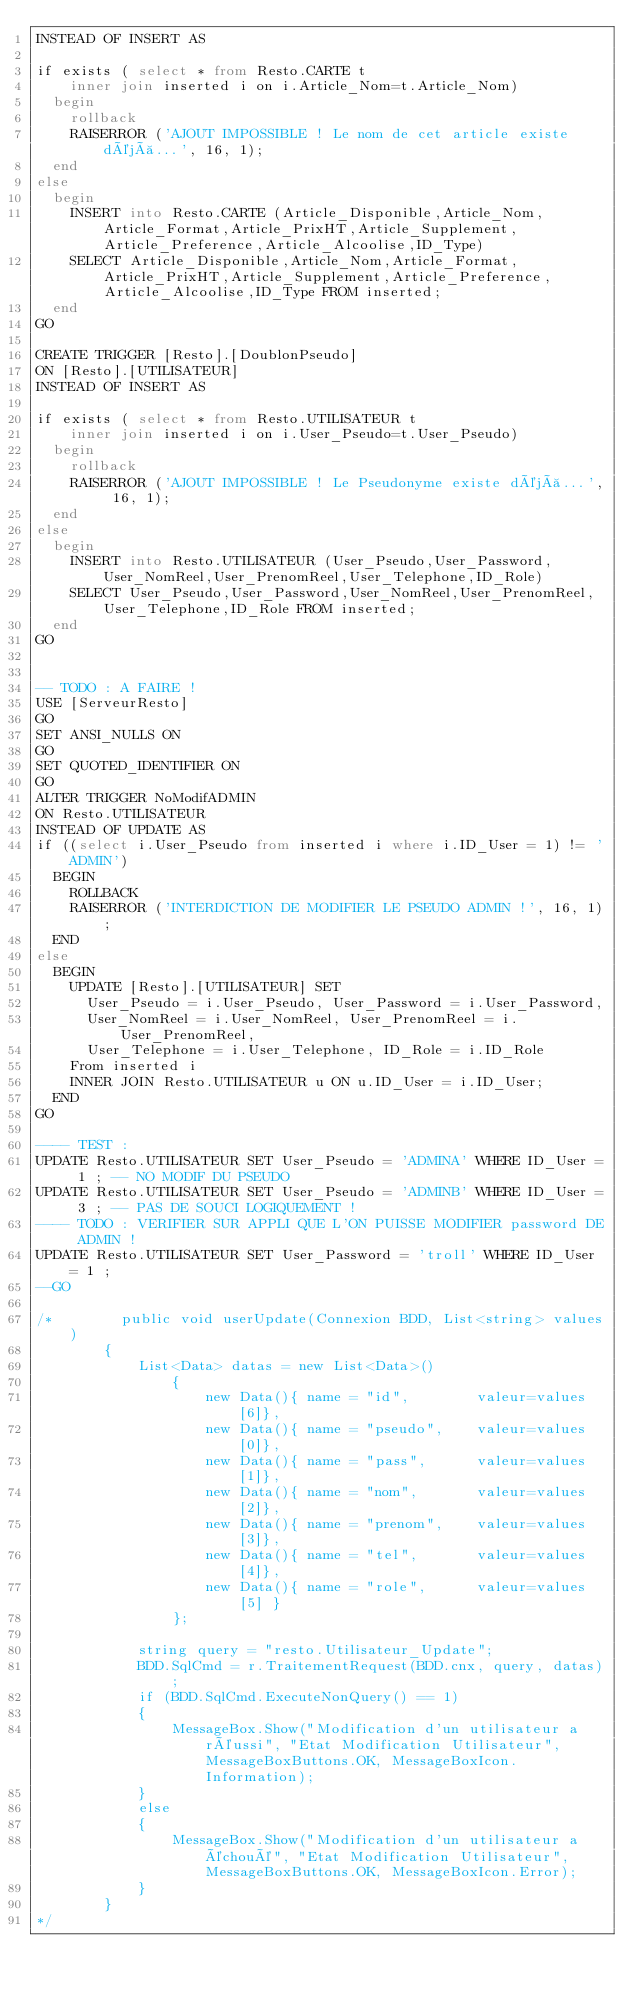Convert code to text. <code><loc_0><loc_0><loc_500><loc_500><_SQL_>INSTEAD OF INSERT AS

if exists ( select * from Resto.CARTE t 
    inner join inserted i on i.Article_Nom=t.Article_Nom)
	begin
		rollback
		RAISERROR ('AJOUT IMPOSSIBLE ! Le nom de cet article existe déjà...', 16, 1);
	end
else
	begin
		INSERT into Resto.CARTE (Article_Disponible,Article_Nom,Article_Format,Article_PrixHT,Article_Supplement,Article_Preference,Article_Alcoolise,ID_Type)
		SELECT Article_Disponible,Article_Nom,Article_Format,Article_PrixHT,Article_Supplement,Article_Preference,Article_Alcoolise,ID_Type FROM inserted;
	end
GO

CREATE TRIGGER [Resto].[DoublonPseudo]
ON [Resto].[UTILISATEUR]
INSTEAD OF INSERT AS

if exists ( select * from Resto.UTILISATEUR t 
    inner join inserted i on i.User_Pseudo=t.User_Pseudo)
	begin
		rollback
		RAISERROR ('AJOUT IMPOSSIBLE ! Le Pseudonyme existe déjà...', 16, 1);
	end
else
	begin
		INSERT into Resto.UTILISATEUR (User_Pseudo,User_Password,User_NomReel,User_PrenomReel,User_Telephone,ID_Role) 
		SELECT User_Pseudo,User_Password,User_NomReel,User_PrenomReel,User_Telephone,ID_Role FROM inserted;
	end
GO


-- TODO : A FAIRE !
USE [ServeurResto]
GO
SET ANSI_NULLS ON
GO
SET QUOTED_IDENTIFIER ON
GO
ALTER TRIGGER NoModifADMIN
ON Resto.UTILISATEUR
INSTEAD OF UPDATE AS
if ((select i.User_Pseudo from inserted i where i.ID_User = 1) != 'ADMIN')
	BEGIN
		ROLLBACK
		RAISERROR ('INTERDICTION DE MODIFIER LE PSEUDO ADMIN !', 16, 1);
	END
else
	BEGIN
		UPDATE [Resto].[UTILISATEUR] SET
			User_Pseudo = i.User_Pseudo, User_Password = i.User_Password, 
			User_NomReel = i.User_NomReel, User_PrenomReel = i.User_PrenomReel, 
			User_Telephone = i.User_Telephone, ID_Role = i.ID_Role
		From inserted i		
		INNER JOIN Resto.UTILISATEUR u ON u.ID_User = i.ID_User;
	END
GO

---- TEST :
UPDATE Resto.UTILISATEUR SET User_Pseudo = 'ADMINA' WHERE ID_User = 1 ; -- NO MODIF DU PSEUDO
UPDATE Resto.UTILISATEUR SET User_Pseudo = 'ADMINB' WHERE ID_User = 3 ; -- PAS DE SOUCI LOGIQUEMENT !
---- TODO : VERIFIER SUR APPLI QUE L'ON PUISSE MODIFIER password DE ADMIN !
UPDATE Resto.UTILISATEUR SET User_Password = 'troll' WHERE ID_User = 1 ;
--GO

/*        public void userUpdate(Connexion BDD, List<string> values)
        {
            List<Data> datas = new List<Data>()
                {
                    new Data(){ name = "id",        valeur=values[6]},
                    new Data(){ name = "pseudo",    valeur=values[0]},
                    new Data(){ name = "pass",      valeur=values[1]},
                    new Data(){ name = "nom",       valeur=values[2]},
                    new Data(){ name = "prenom",    valeur=values[3]},
                    new Data(){ name = "tel",       valeur=values[4]},
                    new Data(){ name = "role",      valeur=values[5] }
                };

            string query = "resto.Utilisateur_Update";
            BDD.SqlCmd = r.TraitementRequest(BDD.cnx, query, datas);
            if (BDD.SqlCmd.ExecuteNonQuery() == 1)
            {
                MessageBox.Show("Modification d'un utilisateur a réussi", "Etat Modification Utilisateur", MessageBoxButtons.OK, MessageBoxIcon.Information);
            }
            else
            {
                MessageBox.Show("Modification d'un utilisateur a échoué", "Etat Modification Utilisateur", MessageBoxButtons.OK, MessageBoxIcon.Error);
            }
        }
*/</code> 